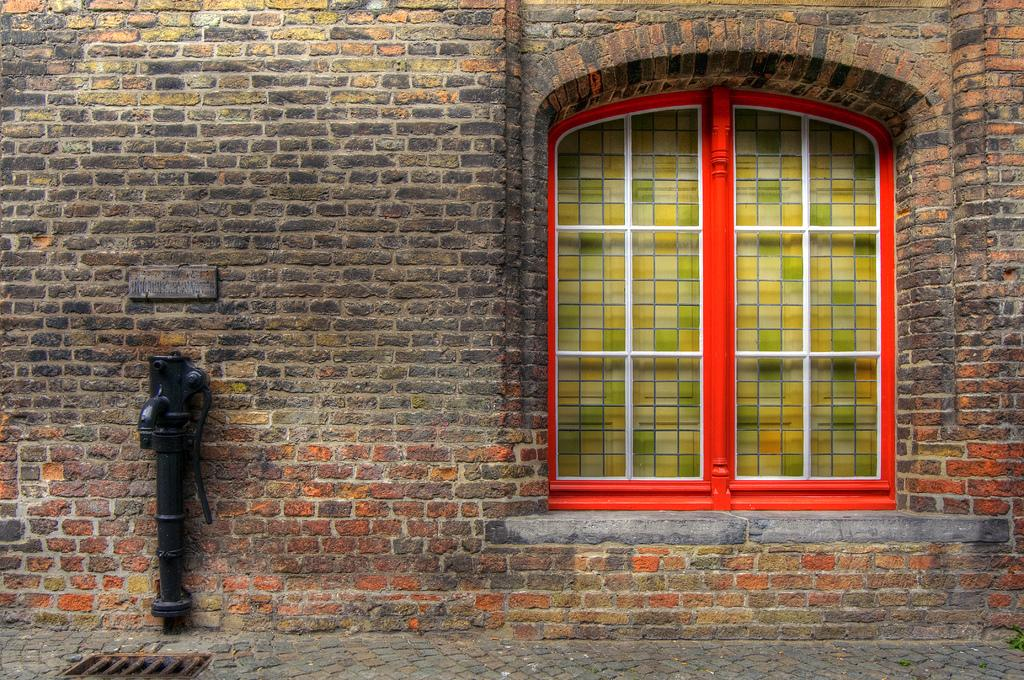What type of structure is visible on the left side of the image? There is a pump on the left side of the image. What can be seen on the right side of the image? There is a window on the right side of the image. What is the main background element in the image? There is a brick wall in the image. How many bridges can be seen crossing over the water in the image? There is no water or bridge present in the image; it features a brick wall, a window, and a pump. What type of lace is draped over the pump in the image? There is no lace present in the image; it only features a pump, a brick wall, and a window. 